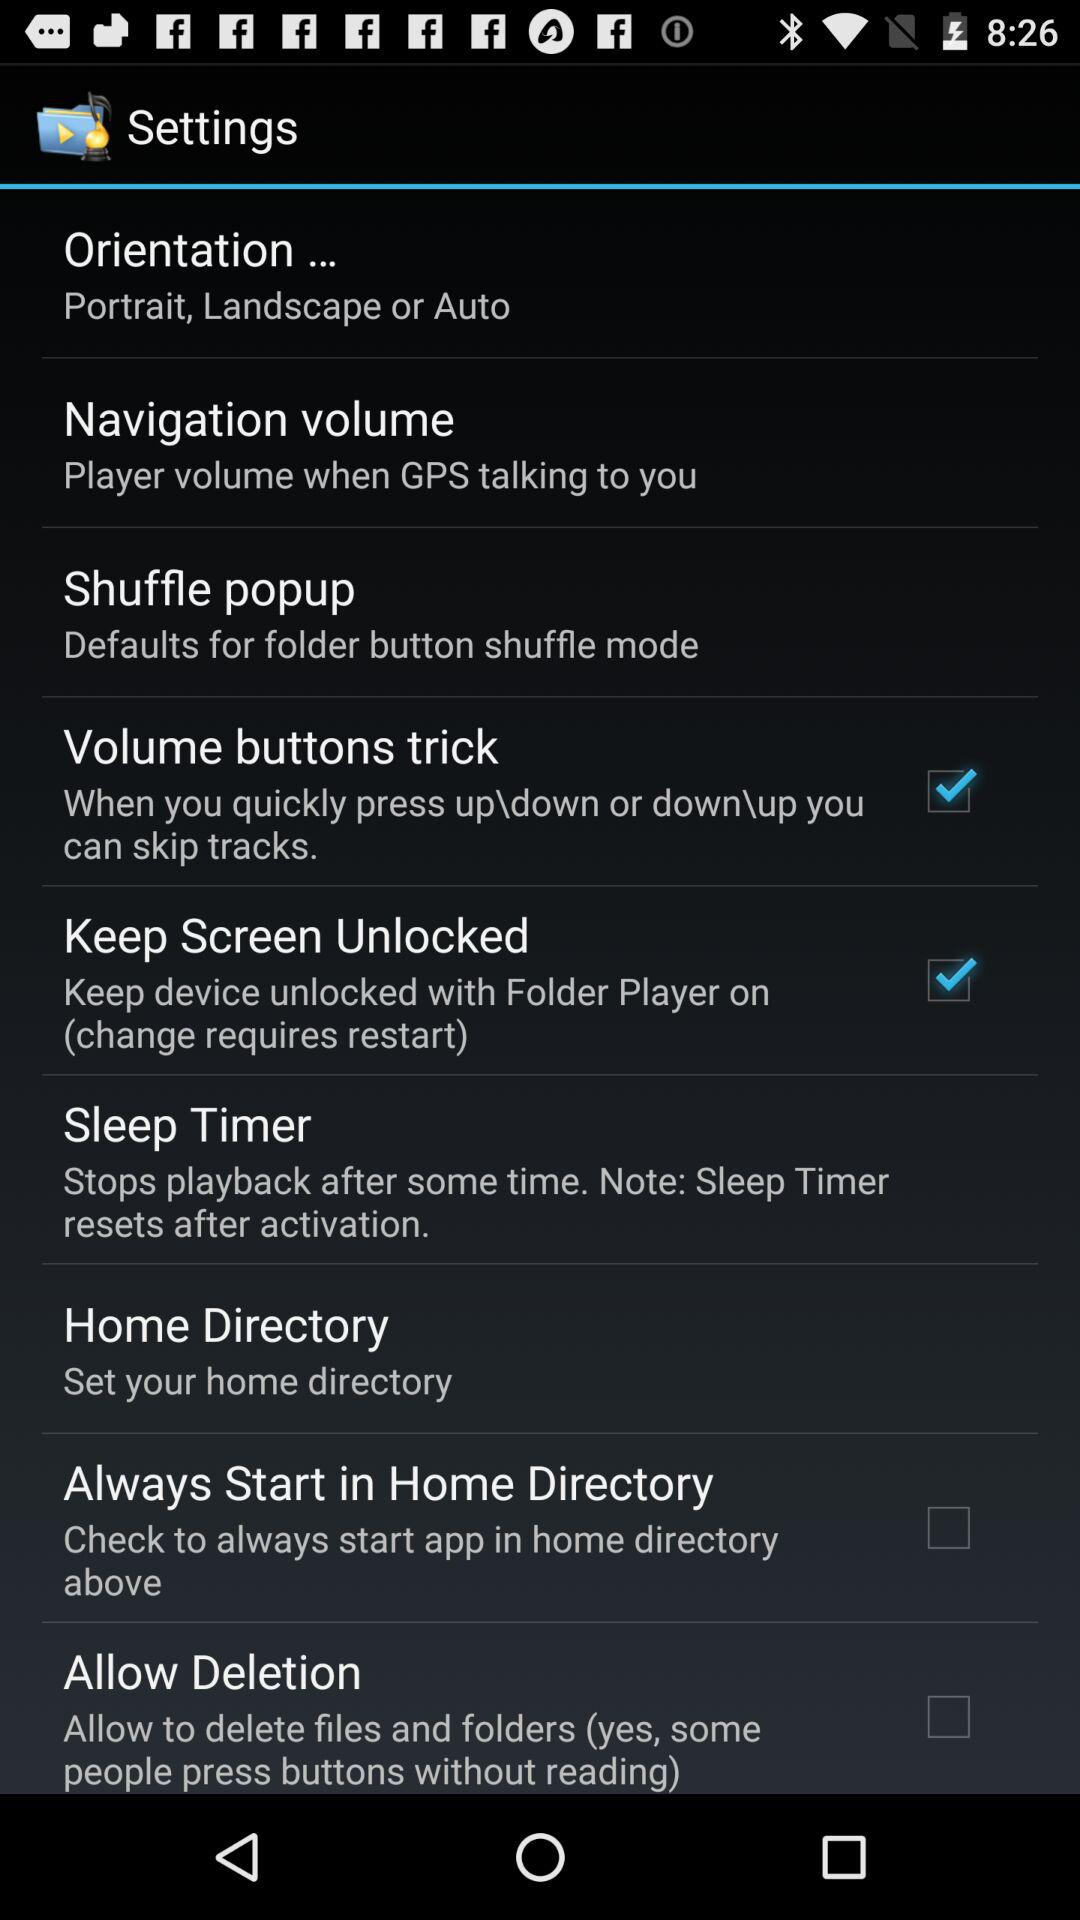Which settings are unchecked? The unchecked settings are "Always Start in Home Directory" and "Allow Deletion". 